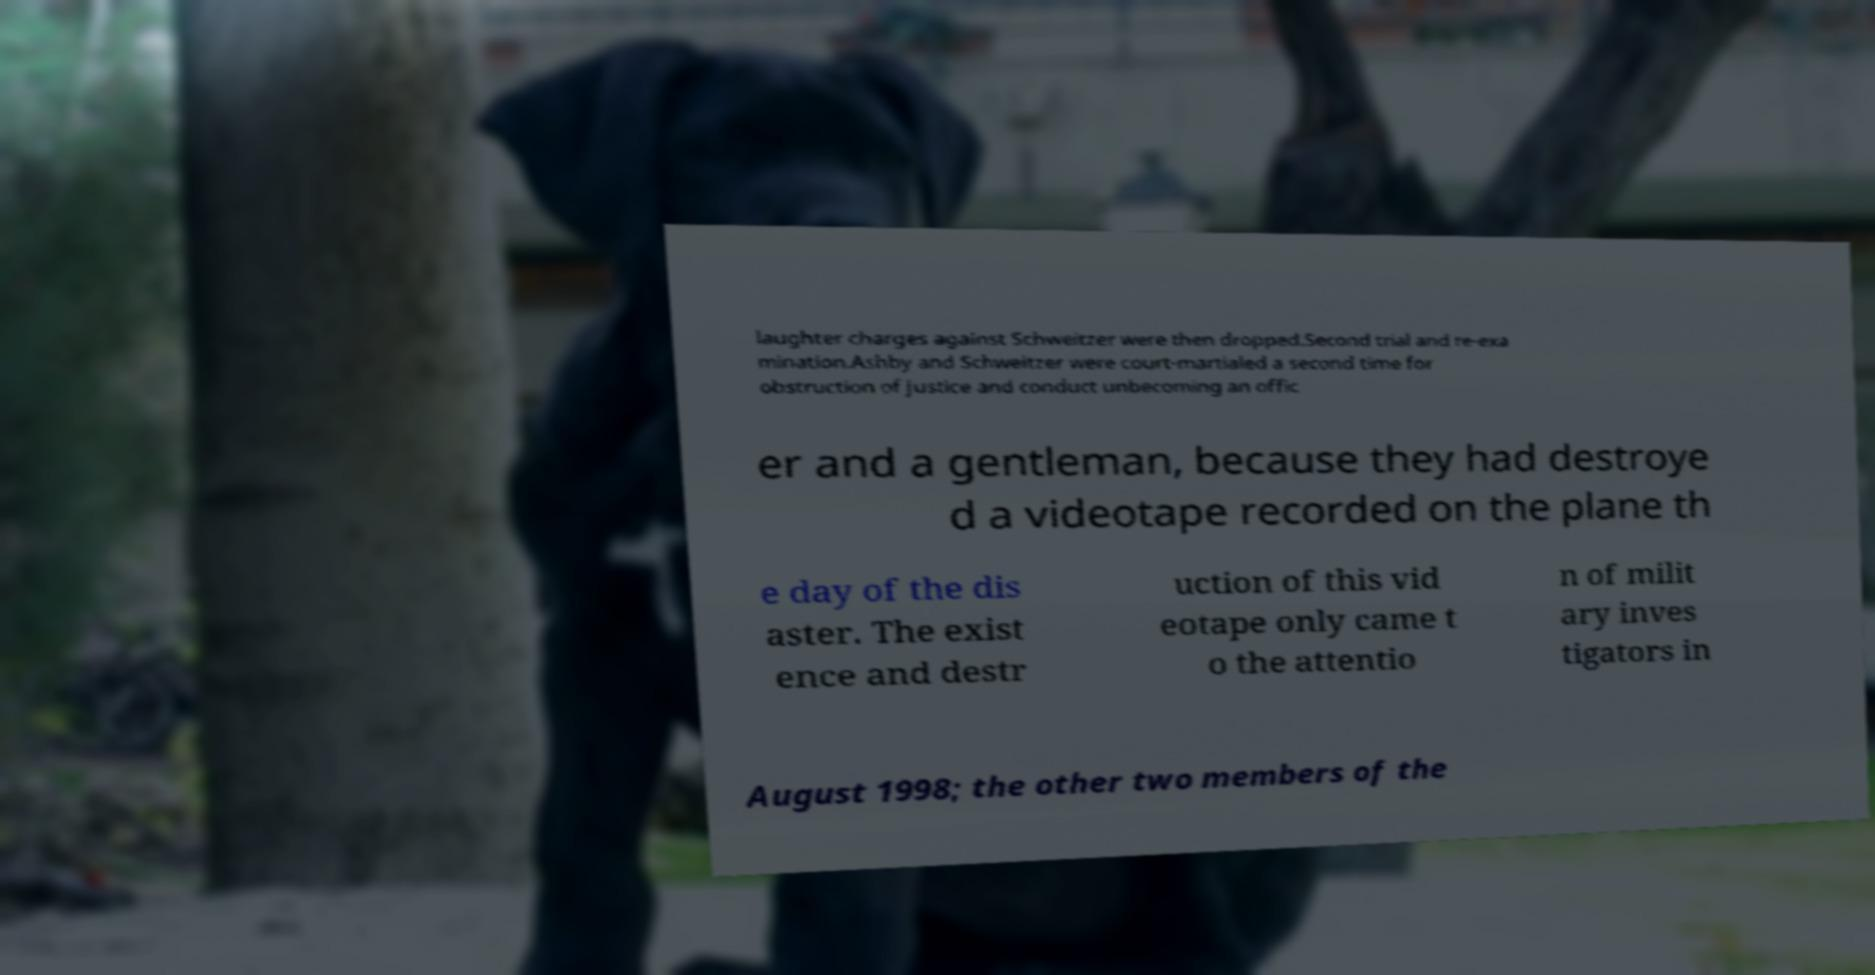Please read and relay the text visible in this image. What does it say? laughter charges against Schweitzer were then dropped.Second trial and re-exa mination.Ashby and Schweitzer were court-martialed a second time for obstruction of justice and conduct unbecoming an offic er and a gentleman, because they had destroye d a videotape recorded on the plane th e day of the dis aster. The exist ence and destr uction of this vid eotape only came t o the attentio n of milit ary inves tigators in August 1998; the other two members of the 